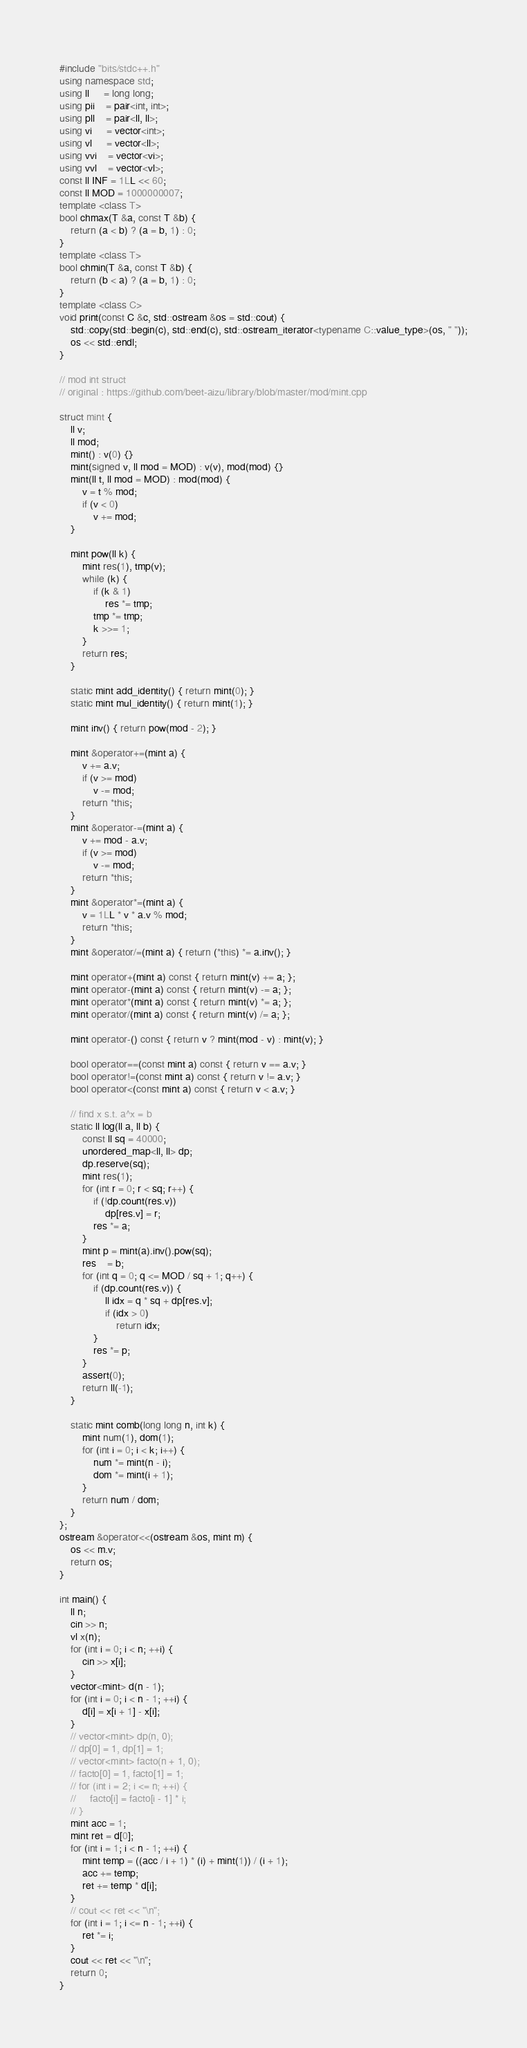Convert code to text. <code><loc_0><loc_0><loc_500><loc_500><_C++_>#include "bits/stdc++.h"
using namespace std;
using ll     = long long;
using pii    = pair<int, int>;
using pll    = pair<ll, ll>;
using vi     = vector<int>;
using vl     = vector<ll>;
using vvi    = vector<vi>;
using vvl    = vector<vl>;
const ll INF = 1LL << 60;
const ll MOD = 1000000007;
template <class T>
bool chmax(T &a, const T &b) {
    return (a < b) ? (a = b, 1) : 0;
}
template <class T>
bool chmin(T &a, const T &b) {
    return (b < a) ? (a = b, 1) : 0;
}
template <class C>
void print(const C &c, std::ostream &os = std::cout) {
    std::copy(std::begin(c), std::end(c), std::ostream_iterator<typename C::value_type>(os, " "));
    os << std::endl;
}

// mod int struct
// original : https://github.com/beet-aizu/library/blob/master/mod/mint.cpp

struct mint {
    ll v;
    ll mod;
    mint() : v(0) {}
    mint(signed v, ll mod = MOD) : v(v), mod(mod) {}
    mint(ll t, ll mod = MOD) : mod(mod) {
        v = t % mod;
        if (v < 0)
            v += mod;
    }

    mint pow(ll k) {
        mint res(1), tmp(v);
        while (k) {
            if (k & 1)
                res *= tmp;
            tmp *= tmp;
            k >>= 1;
        }
        return res;
    }

    static mint add_identity() { return mint(0); }
    static mint mul_identity() { return mint(1); }

    mint inv() { return pow(mod - 2); }

    mint &operator+=(mint a) {
        v += a.v;
        if (v >= mod)
            v -= mod;
        return *this;
    }
    mint &operator-=(mint a) {
        v += mod - a.v;
        if (v >= mod)
            v -= mod;
        return *this;
    }
    mint &operator*=(mint a) {
        v = 1LL * v * a.v % mod;
        return *this;
    }
    mint &operator/=(mint a) { return (*this) *= a.inv(); }

    mint operator+(mint a) const { return mint(v) += a; };
    mint operator-(mint a) const { return mint(v) -= a; };
    mint operator*(mint a) const { return mint(v) *= a; };
    mint operator/(mint a) const { return mint(v) /= a; };

    mint operator-() const { return v ? mint(mod - v) : mint(v); }

    bool operator==(const mint a) const { return v == a.v; }
    bool operator!=(const mint a) const { return v != a.v; }
    bool operator<(const mint a) const { return v < a.v; }

    // find x s.t. a^x = b
    static ll log(ll a, ll b) {
        const ll sq = 40000;
        unordered_map<ll, ll> dp;
        dp.reserve(sq);
        mint res(1);
        for (int r = 0; r < sq; r++) {
            if (!dp.count(res.v))
                dp[res.v] = r;
            res *= a;
        }
        mint p = mint(a).inv().pow(sq);
        res    = b;
        for (int q = 0; q <= MOD / sq + 1; q++) {
            if (dp.count(res.v)) {
                ll idx = q * sq + dp[res.v];
                if (idx > 0)
                    return idx;
            }
            res *= p;
        }
        assert(0);
        return ll(-1);
    }

    static mint comb(long long n, int k) {
        mint num(1), dom(1);
        for (int i = 0; i < k; i++) {
            num *= mint(n - i);
            dom *= mint(i + 1);
        }
        return num / dom;
    }
};
ostream &operator<<(ostream &os, mint m) {
    os << m.v;
    return os;
}

int main() {
    ll n;
    cin >> n;
    vl x(n);
    for (int i = 0; i < n; ++i) {
        cin >> x[i];
    }
    vector<mint> d(n - 1);
    for (int i = 0; i < n - 1; ++i) {
        d[i] = x[i + 1] - x[i];
    }
    // vector<mint> dp(n, 0);
    // dp[0] = 1, dp[1] = 1;
    // vector<mint> facto(n + 1, 0);
    // facto[0] = 1, facto[1] = 1;
    // for (int i = 2; i <= n; ++i) {
    //     facto[i] = facto[i - 1] * i;
    // }
    mint acc = 1;
    mint ret = d[0];
    for (int i = 1; i < n - 1; ++i) {
        mint temp = ((acc / i + 1) * (i) + mint(1)) / (i + 1);
        acc += temp;
        ret += temp * d[i];
    }
    // cout << ret << "\n";
    for (int i = 1; i <= n - 1; ++i) {
        ret *= i;
    }
    cout << ret << "\n";
    return 0;
}</code> 